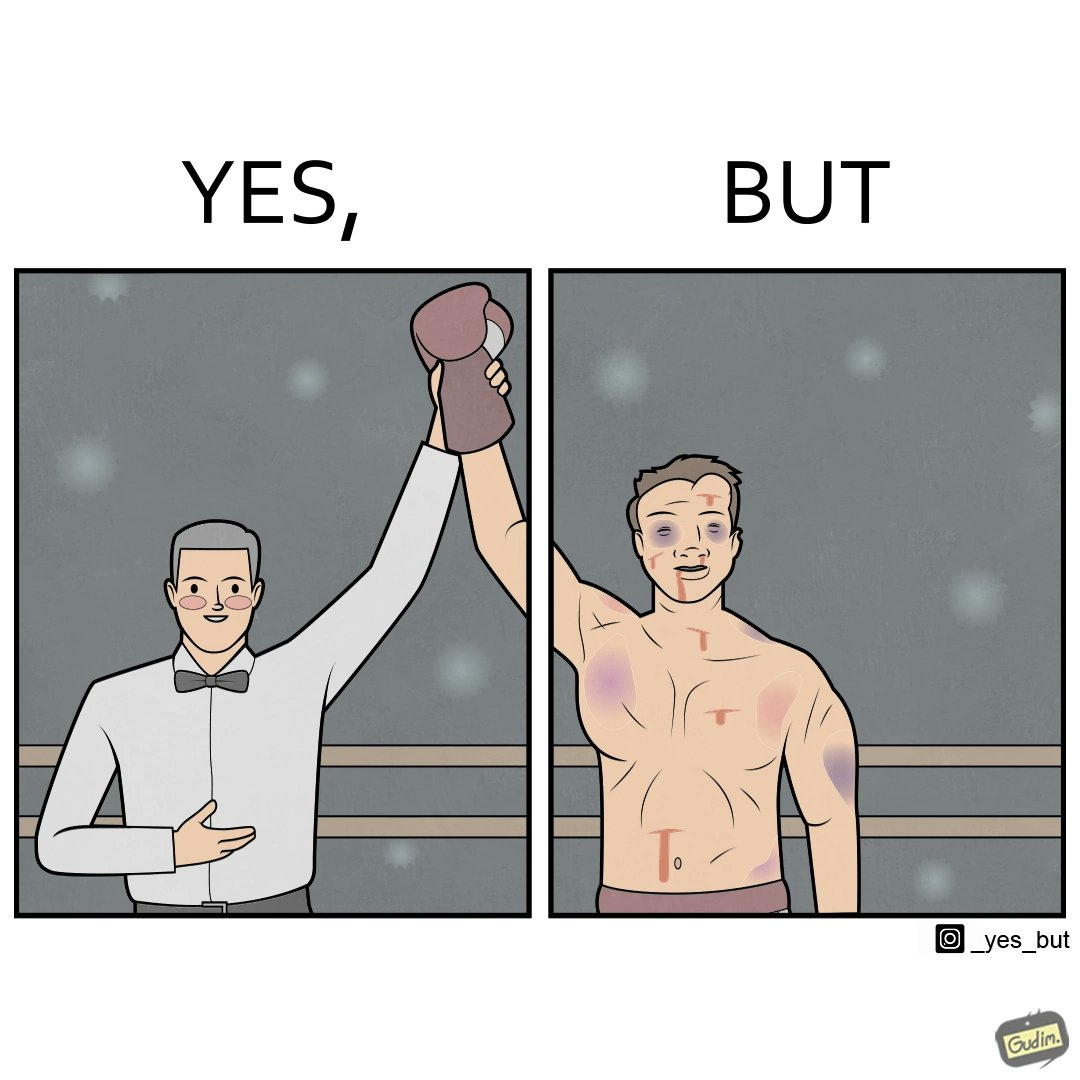Describe the satirical element in this image. The image is ironic because even though a boxer has won the match and it is supposed to be a moment of celebration, the boxer got bruised in several places during the match. This is an illustration of what hurdles a person has to go through in order to succeed. 